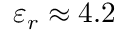<formula> <loc_0><loc_0><loc_500><loc_500>\varepsilon _ { r } \approx 4 . 2</formula> 